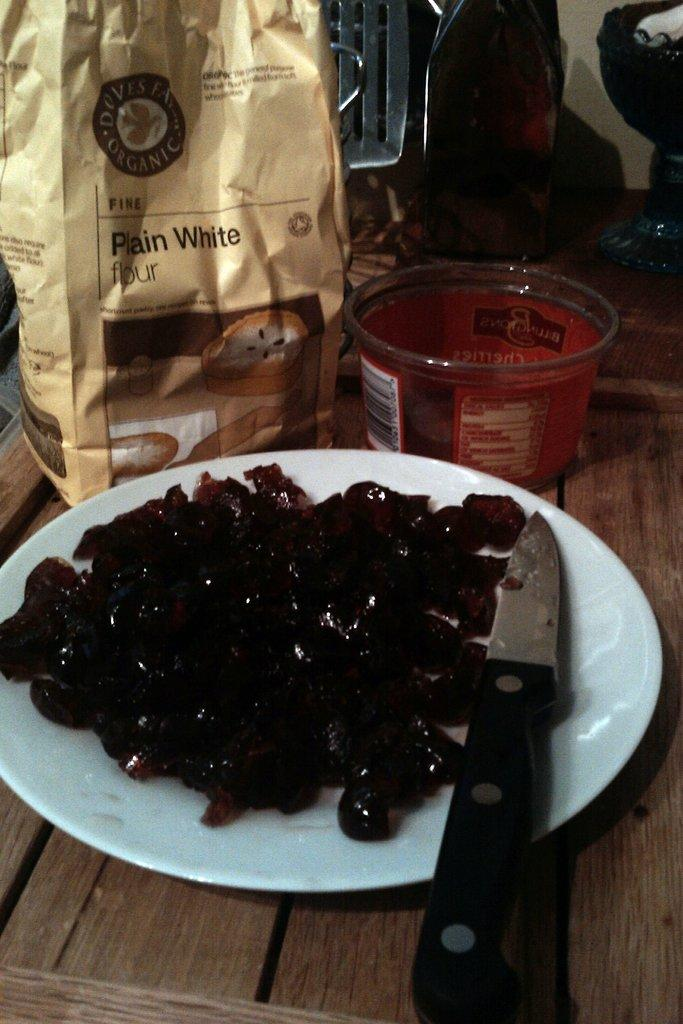What is on the plate in the image? There is a knife and a food item on the plate in the image. What other dishware is present in the image? There is a bowl in the image. What type of covering is on the bowl? There is a paper cover on the bowl. What material is the wooden object made of? The wooden object is present in the image. What is behind the paper cover? There are items behind the paper cover. Can you see a ghost flying over the wooden object in the image? No, there is no ghost present in the image. Is there a plane visible in the image? No, there is no plane present in the image. 